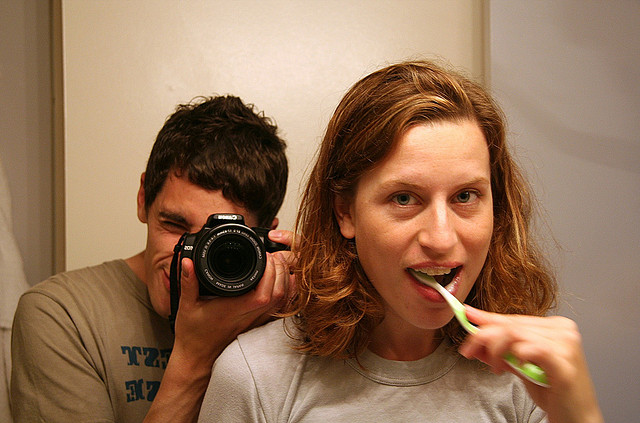Please transcribe the text in this image. TZ5 